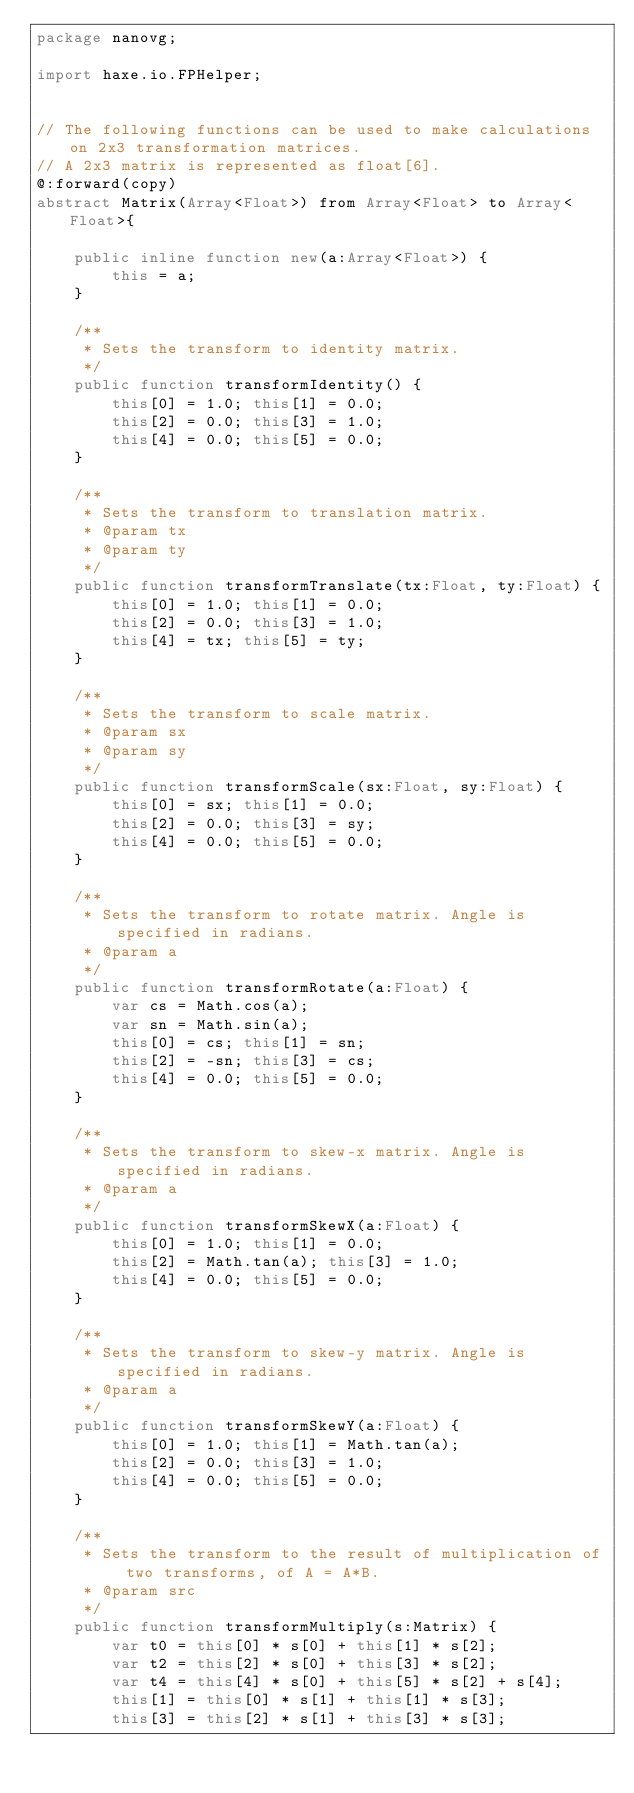Convert code to text. <code><loc_0><loc_0><loc_500><loc_500><_Haxe_>package nanovg;

import haxe.io.FPHelper;


// The following functions can be used to make calculations on 2x3 transformation matrices.
// A 2x3 matrix is represented as float[6].
@:forward(copy)
abstract Matrix(Array<Float>) from Array<Float> to Array<Float>{

    public inline function new(a:Array<Float>) {
        this = a;
    }

    /**
     * Sets the transform to identity matrix.
     */
    public function transformIdentity() {
        this[0] = 1.0; this[1] = 0.0;
        this[2] = 0.0; this[3] = 1.0;
        this[4] = 0.0; this[5] = 0.0;
    }

    /**
     * Sets the transform to translation matrix.
     * @param tx 
     * @param ty 
     */
    public function transformTranslate(tx:Float, ty:Float) {
        this[0] = 1.0; this[1] = 0.0;
        this[2] = 0.0; this[3] = 1.0;
        this[4] = tx; this[5] = ty;
    }

    /**
     * Sets the transform to scale matrix.
     * @param sx 
     * @param sy 
     */
    public function transformScale(sx:Float, sy:Float) {
        this[0] = sx; this[1] = 0.0;
        this[2] = 0.0; this[3] = sy;
        this[4] = 0.0; this[5] = 0.0;
    }

    /**
     * Sets the transform to rotate matrix. Angle is specified in radians.
     * @param a 
     */
    public function transformRotate(a:Float) {
        var cs = Math.cos(a);
        var sn = Math.sin(a);
        this[0] = cs; this[1] = sn;
        this[2] = -sn; this[3] = cs;
        this[4] = 0.0; this[5] = 0.0;
    }

    /**
     * Sets the transform to skew-x matrix. Angle is specified in radians.
     * @param a 
     */
    public function transformSkewX(a:Float) {
        this[0] = 1.0; this[1] = 0.0;
        this[2] = Math.tan(a); this[3] = 1.0;
        this[4] = 0.0; this[5] = 0.0;
    }

    /**
     * Sets the transform to skew-y matrix. Angle is specified in radians.
     * @param a 
     */
    public function transformSkewY(a:Float) {
        this[0] = 1.0; this[1] = Math.tan(a);
        this[2] = 0.0; this[3] = 1.0;
        this[4] = 0.0; this[5] = 0.0;
    }

    /**
     * Sets the transform to the result of multiplication of two transforms, of A = A*B.
     * @param src 
     */
    public function transformMultiply(s:Matrix) {
        var t0 = this[0] * s[0] + this[1] * s[2];
        var t2 = this[2] * s[0] + this[3] * s[2];
        var t4 = this[4] * s[0] + this[5] * s[2] + s[4];
        this[1] = this[0] * s[1] + this[1] * s[3];
        this[3] = this[2] * s[1] + this[3] * s[3];</code> 